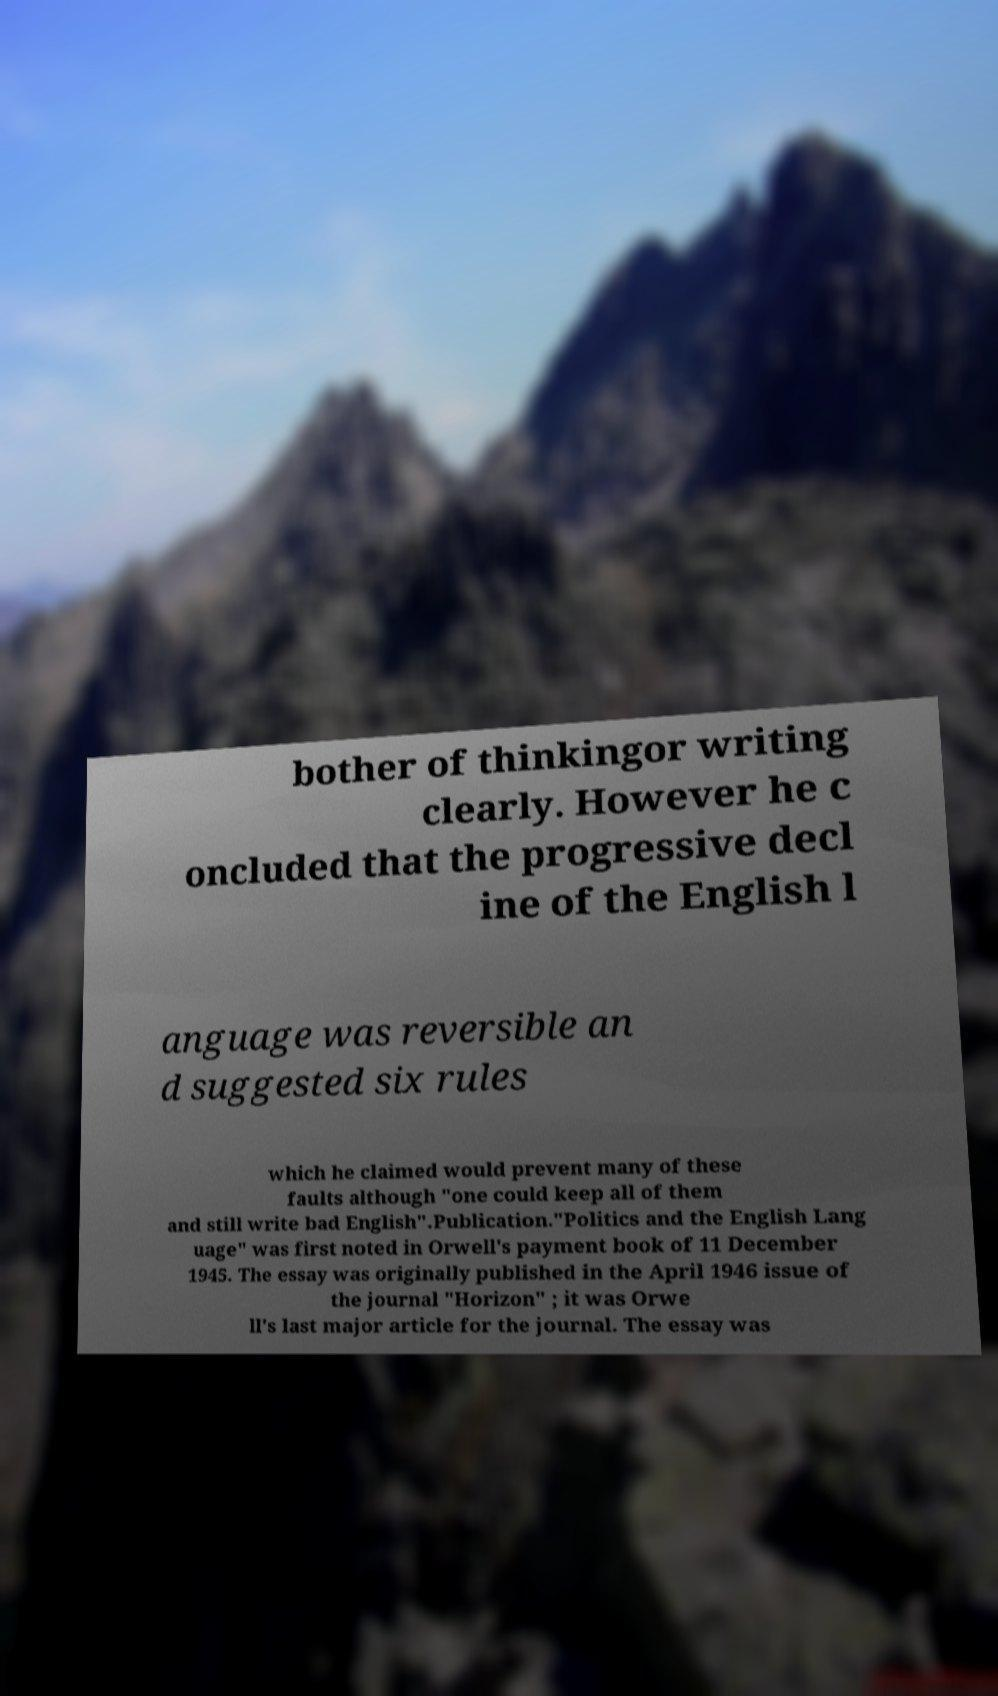Could you assist in decoding the text presented in this image and type it out clearly? bother of thinkingor writing clearly. However he c oncluded that the progressive decl ine of the English l anguage was reversible an d suggested six rules which he claimed would prevent many of these faults although "one could keep all of them and still write bad English".Publication."Politics and the English Lang uage" was first noted in Orwell's payment book of 11 December 1945. The essay was originally published in the April 1946 issue of the journal "Horizon" ; it was Orwe ll's last major article for the journal. The essay was 